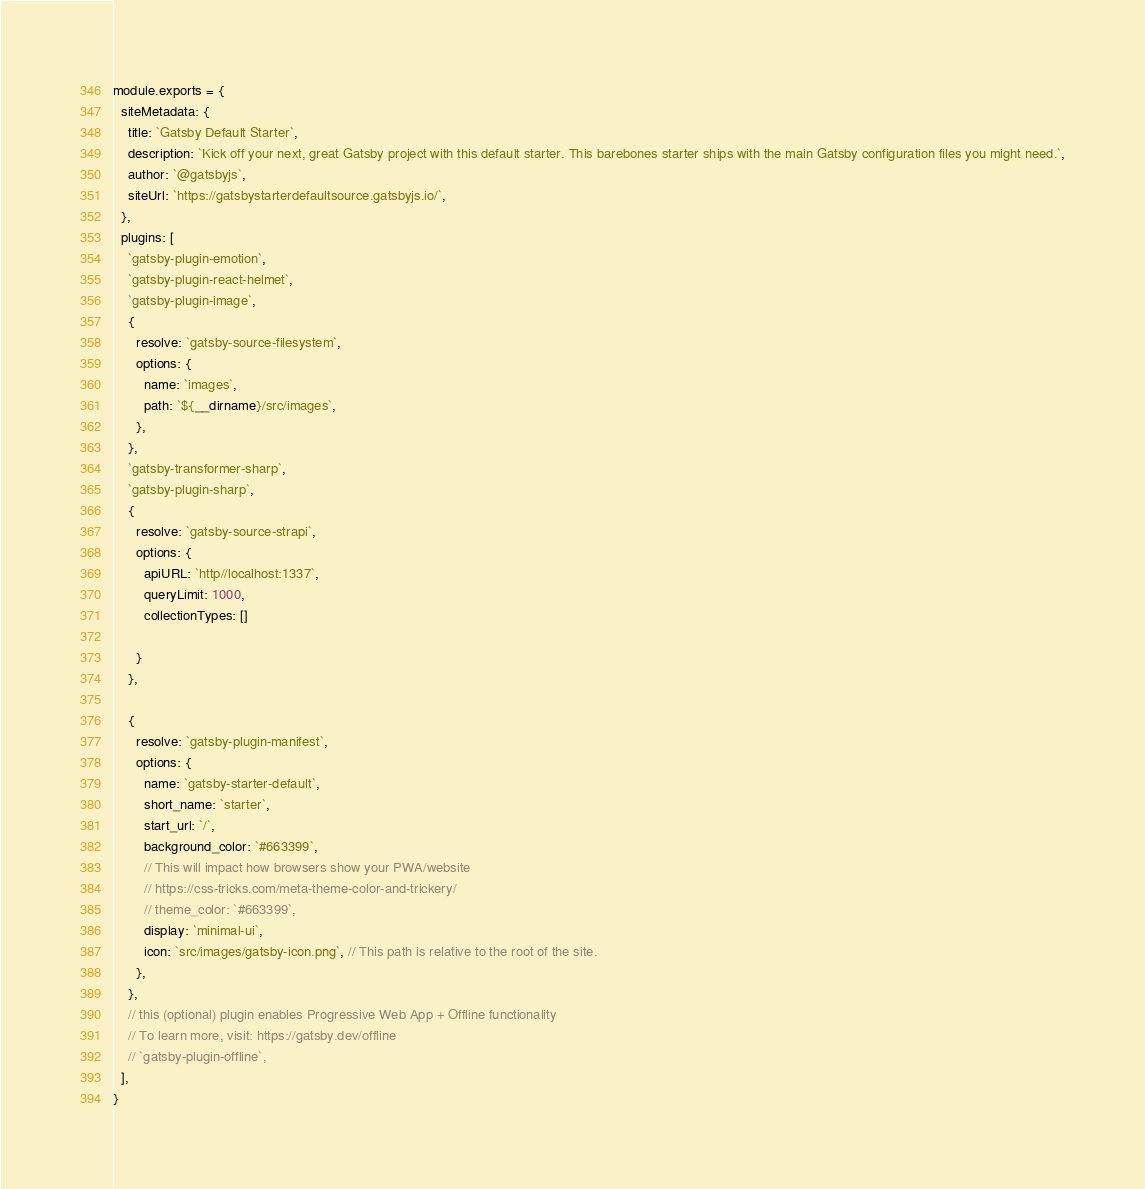<code> <loc_0><loc_0><loc_500><loc_500><_JavaScript_>module.exports = {
  siteMetadata: {
    title: `Gatsby Default Starter`,
    description: `Kick off your next, great Gatsby project with this default starter. This barebones starter ships with the main Gatsby configuration files you might need.`,
    author: `@gatsbyjs`,
    siteUrl: `https://gatsbystarterdefaultsource.gatsbyjs.io/`,
  },
  plugins: [
    `gatsby-plugin-emotion`,
    `gatsby-plugin-react-helmet`,
    `gatsby-plugin-image`,
    {
      resolve: `gatsby-source-filesystem`,
      options: {
        name: `images`,
        path: `${__dirname}/src/images`,
      },
    },
    `gatsby-transformer-sharp`,
    `gatsby-plugin-sharp`,
    {
      resolve: `gatsby-source-strapi`,
      options: {
        apiURL: `http//localhost:1337`,
        queryLimit: 1000,
        collectionTypes: []

      }
    },
  
    {
      resolve: `gatsby-plugin-manifest`,
      options: {
        name: `gatsby-starter-default`,
        short_name: `starter`,
        start_url: `/`,
        background_color: `#663399`,
        // This will impact how browsers show your PWA/website
        // https://css-tricks.com/meta-theme-color-and-trickery/
        // theme_color: `#663399`,
        display: `minimal-ui`,
        icon: `src/images/gatsby-icon.png`, // This path is relative to the root of the site.
      },
    },
    // this (optional) plugin enables Progressive Web App + Offline functionality
    // To learn more, visit: https://gatsby.dev/offline
    // `gatsby-plugin-offline`,
  ],
}
</code> 